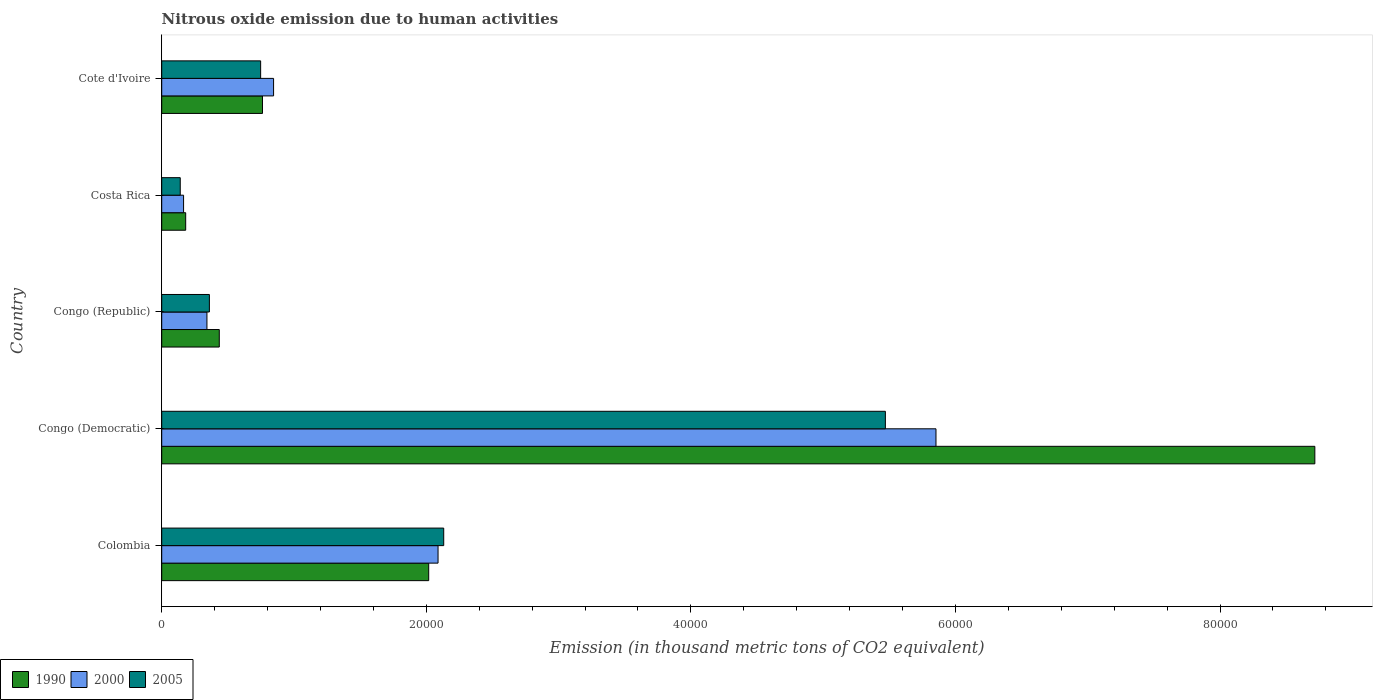How many bars are there on the 3rd tick from the top?
Your answer should be very brief. 3. In how many cases, is the number of bars for a given country not equal to the number of legend labels?
Provide a short and direct response. 0. What is the amount of nitrous oxide emitted in 1990 in Costa Rica?
Make the answer very short. 1812.5. Across all countries, what is the maximum amount of nitrous oxide emitted in 2000?
Provide a succinct answer. 5.85e+04. Across all countries, what is the minimum amount of nitrous oxide emitted in 2005?
Offer a very short reply. 1401. In which country was the amount of nitrous oxide emitted in 1990 maximum?
Offer a very short reply. Congo (Democratic). In which country was the amount of nitrous oxide emitted in 2005 minimum?
Your answer should be very brief. Costa Rica. What is the total amount of nitrous oxide emitted in 1990 in the graph?
Provide a succinct answer. 1.21e+05. What is the difference between the amount of nitrous oxide emitted in 1990 in Congo (Democratic) and that in Cote d'Ivoire?
Keep it short and to the point. 7.95e+04. What is the difference between the amount of nitrous oxide emitted in 1990 in Cote d'Ivoire and the amount of nitrous oxide emitted in 2005 in Costa Rica?
Provide a succinct answer. 6217. What is the average amount of nitrous oxide emitted in 1990 per country?
Ensure brevity in your answer.  2.42e+04. What is the difference between the amount of nitrous oxide emitted in 1990 and amount of nitrous oxide emitted in 2005 in Costa Rica?
Provide a short and direct response. 411.5. What is the ratio of the amount of nitrous oxide emitted in 2000 in Congo (Democratic) to that in Congo (Republic)?
Your answer should be compact. 17.12. Is the amount of nitrous oxide emitted in 2005 in Costa Rica less than that in Cote d'Ivoire?
Provide a short and direct response. Yes. Is the difference between the amount of nitrous oxide emitted in 1990 in Congo (Democratic) and Costa Rica greater than the difference between the amount of nitrous oxide emitted in 2005 in Congo (Democratic) and Costa Rica?
Your answer should be compact. Yes. What is the difference between the highest and the second highest amount of nitrous oxide emitted in 2005?
Make the answer very short. 3.34e+04. What is the difference between the highest and the lowest amount of nitrous oxide emitted in 2000?
Keep it short and to the point. 5.69e+04. What does the 2nd bar from the top in Cote d'Ivoire represents?
Your response must be concise. 2000. How many bars are there?
Make the answer very short. 15. How many countries are there in the graph?
Offer a terse response. 5. What is the difference between two consecutive major ticks on the X-axis?
Offer a terse response. 2.00e+04. Are the values on the major ticks of X-axis written in scientific E-notation?
Offer a very short reply. No. Where does the legend appear in the graph?
Provide a succinct answer. Bottom left. How many legend labels are there?
Keep it short and to the point. 3. How are the legend labels stacked?
Offer a terse response. Horizontal. What is the title of the graph?
Keep it short and to the point. Nitrous oxide emission due to human activities. What is the label or title of the X-axis?
Offer a terse response. Emission (in thousand metric tons of CO2 equivalent). What is the label or title of the Y-axis?
Provide a succinct answer. Country. What is the Emission (in thousand metric tons of CO2 equivalent) of 1990 in Colombia?
Ensure brevity in your answer.  2.02e+04. What is the Emission (in thousand metric tons of CO2 equivalent) in 2000 in Colombia?
Keep it short and to the point. 2.09e+04. What is the Emission (in thousand metric tons of CO2 equivalent) in 2005 in Colombia?
Your answer should be very brief. 2.13e+04. What is the Emission (in thousand metric tons of CO2 equivalent) in 1990 in Congo (Democratic)?
Your response must be concise. 8.72e+04. What is the Emission (in thousand metric tons of CO2 equivalent) in 2000 in Congo (Democratic)?
Ensure brevity in your answer.  5.85e+04. What is the Emission (in thousand metric tons of CO2 equivalent) of 2005 in Congo (Democratic)?
Offer a terse response. 5.47e+04. What is the Emission (in thousand metric tons of CO2 equivalent) in 1990 in Congo (Republic)?
Provide a short and direct response. 4351.5. What is the Emission (in thousand metric tons of CO2 equivalent) in 2000 in Congo (Republic)?
Offer a very short reply. 3418.3. What is the Emission (in thousand metric tons of CO2 equivalent) in 2005 in Congo (Republic)?
Your response must be concise. 3603.5. What is the Emission (in thousand metric tons of CO2 equivalent) in 1990 in Costa Rica?
Your response must be concise. 1812.5. What is the Emission (in thousand metric tons of CO2 equivalent) of 2000 in Costa Rica?
Offer a very short reply. 1653.2. What is the Emission (in thousand metric tons of CO2 equivalent) of 2005 in Costa Rica?
Your answer should be compact. 1401. What is the Emission (in thousand metric tons of CO2 equivalent) in 1990 in Cote d'Ivoire?
Your answer should be very brief. 7618. What is the Emission (in thousand metric tons of CO2 equivalent) of 2000 in Cote d'Ivoire?
Your answer should be compact. 8455.7. What is the Emission (in thousand metric tons of CO2 equivalent) in 2005 in Cote d'Ivoire?
Your answer should be very brief. 7477.7. Across all countries, what is the maximum Emission (in thousand metric tons of CO2 equivalent) in 1990?
Your response must be concise. 8.72e+04. Across all countries, what is the maximum Emission (in thousand metric tons of CO2 equivalent) in 2000?
Make the answer very short. 5.85e+04. Across all countries, what is the maximum Emission (in thousand metric tons of CO2 equivalent) in 2005?
Your answer should be compact. 5.47e+04. Across all countries, what is the minimum Emission (in thousand metric tons of CO2 equivalent) of 1990?
Provide a succinct answer. 1812.5. Across all countries, what is the minimum Emission (in thousand metric tons of CO2 equivalent) in 2000?
Offer a very short reply. 1653.2. Across all countries, what is the minimum Emission (in thousand metric tons of CO2 equivalent) in 2005?
Ensure brevity in your answer.  1401. What is the total Emission (in thousand metric tons of CO2 equivalent) of 1990 in the graph?
Provide a succinct answer. 1.21e+05. What is the total Emission (in thousand metric tons of CO2 equivalent) of 2000 in the graph?
Ensure brevity in your answer.  9.29e+04. What is the total Emission (in thousand metric tons of CO2 equivalent) in 2005 in the graph?
Offer a very short reply. 8.85e+04. What is the difference between the Emission (in thousand metric tons of CO2 equivalent) of 1990 in Colombia and that in Congo (Democratic)?
Ensure brevity in your answer.  -6.70e+04. What is the difference between the Emission (in thousand metric tons of CO2 equivalent) of 2000 in Colombia and that in Congo (Democratic)?
Your response must be concise. -3.76e+04. What is the difference between the Emission (in thousand metric tons of CO2 equivalent) in 2005 in Colombia and that in Congo (Democratic)?
Offer a very short reply. -3.34e+04. What is the difference between the Emission (in thousand metric tons of CO2 equivalent) of 1990 in Colombia and that in Congo (Republic)?
Your answer should be very brief. 1.58e+04. What is the difference between the Emission (in thousand metric tons of CO2 equivalent) in 2000 in Colombia and that in Congo (Republic)?
Keep it short and to the point. 1.75e+04. What is the difference between the Emission (in thousand metric tons of CO2 equivalent) in 2005 in Colombia and that in Congo (Republic)?
Make the answer very short. 1.77e+04. What is the difference between the Emission (in thousand metric tons of CO2 equivalent) of 1990 in Colombia and that in Costa Rica?
Ensure brevity in your answer.  1.84e+04. What is the difference between the Emission (in thousand metric tons of CO2 equivalent) of 2000 in Colombia and that in Costa Rica?
Ensure brevity in your answer.  1.92e+04. What is the difference between the Emission (in thousand metric tons of CO2 equivalent) in 2005 in Colombia and that in Costa Rica?
Make the answer very short. 1.99e+04. What is the difference between the Emission (in thousand metric tons of CO2 equivalent) of 1990 in Colombia and that in Cote d'Ivoire?
Your response must be concise. 1.26e+04. What is the difference between the Emission (in thousand metric tons of CO2 equivalent) of 2000 in Colombia and that in Cote d'Ivoire?
Provide a short and direct response. 1.24e+04. What is the difference between the Emission (in thousand metric tons of CO2 equivalent) of 2005 in Colombia and that in Cote d'Ivoire?
Make the answer very short. 1.38e+04. What is the difference between the Emission (in thousand metric tons of CO2 equivalent) of 1990 in Congo (Democratic) and that in Congo (Republic)?
Provide a succinct answer. 8.28e+04. What is the difference between the Emission (in thousand metric tons of CO2 equivalent) in 2000 in Congo (Democratic) and that in Congo (Republic)?
Provide a short and direct response. 5.51e+04. What is the difference between the Emission (in thousand metric tons of CO2 equivalent) of 2005 in Congo (Democratic) and that in Congo (Republic)?
Your answer should be compact. 5.11e+04. What is the difference between the Emission (in thousand metric tons of CO2 equivalent) of 1990 in Congo (Democratic) and that in Costa Rica?
Offer a terse response. 8.54e+04. What is the difference between the Emission (in thousand metric tons of CO2 equivalent) in 2000 in Congo (Democratic) and that in Costa Rica?
Provide a succinct answer. 5.69e+04. What is the difference between the Emission (in thousand metric tons of CO2 equivalent) in 2005 in Congo (Democratic) and that in Costa Rica?
Ensure brevity in your answer.  5.33e+04. What is the difference between the Emission (in thousand metric tons of CO2 equivalent) in 1990 in Congo (Democratic) and that in Cote d'Ivoire?
Keep it short and to the point. 7.95e+04. What is the difference between the Emission (in thousand metric tons of CO2 equivalent) in 2000 in Congo (Democratic) and that in Cote d'Ivoire?
Give a very brief answer. 5.01e+04. What is the difference between the Emission (in thousand metric tons of CO2 equivalent) of 2005 in Congo (Democratic) and that in Cote d'Ivoire?
Ensure brevity in your answer.  4.72e+04. What is the difference between the Emission (in thousand metric tons of CO2 equivalent) of 1990 in Congo (Republic) and that in Costa Rica?
Your response must be concise. 2539. What is the difference between the Emission (in thousand metric tons of CO2 equivalent) in 2000 in Congo (Republic) and that in Costa Rica?
Ensure brevity in your answer.  1765.1. What is the difference between the Emission (in thousand metric tons of CO2 equivalent) of 2005 in Congo (Republic) and that in Costa Rica?
Provide a short and direct response. 2202.5. What is the difference between the Emission (in thousand metric tons of CO2 equivalent) in 1990 in Congo (Republic) and that in Cote d'Ivoire?
Give a very brief answer. -3266.5. What is the difference between the Emission (in thousand metric tons of CO2 equivalent) in 2000 in Congo (Republic) and that in Cote d'Ivoire?
Keep it short and to the point. -5037.4. What is the difference between the Emission (in thousand metric tons of CO2 equivalent) in 2005 in Congo (Republic) and that in Cote d'Ivoire?
Your response must be concise. -3874.2. What is the difference between the Emission (in thousand metric tons of CO2 equivalent) of 1990 in Costa Rica and that in Cote d'Ivoire?
Ensure brevity in your answer.  -5805.5. What is the difference between the Emission (in thousand metric tons of CO2 equivalent) in 2000 in Costa Rica and that in Cote d'Ivoire?
Give a very brief answer. -6802.5. What is the difference between the Emission (in thousand metric tons of CO2 equivalent) of 2005 in Costa Rica and that in Cote d'Ivoire?
Give a very brief answer. -6076.7. What is the difference between the Emission (in thousand metric tons of CO2 equivalent) of 1990 in Colombia and the Emission (in thousand metric tons of CO2 equivalent) of 2000 in Congo (Democratic)?
Give a very brief answer. -3.83e+04. What is the difference between the Emission (in thousand metric tons of CO2 equivalent) of 1990 in Colombia and the Emission (in thousand metric tons of CO2 equivalent) of 2005 in Congo (Democratic)?
Provide a succinct answer. -3.45e+04. What is the difference between the Emission (in thousand metric tons of CO2 equivalent) in 2000 in Colombia and the Emission (in thousand metric tons of CO2 equivalent) in 2005 in Congo (Democratic)?
Keep it short and to the point. -3.38e+04. What is the difference between the Emission (in thousand metric tons of CO2 equivalent) of 1990 in Colombia and the Emission (in thousand metric tons of CO2 equivalent) of 2000 in Congo (Republic)?
Offer a very short reply. 1.68e+04. What is the difference between the Emission (in thousand metric tons of CO2 equivalent) in 1990 in Colombia and the Emission (in thousand metric tons of CO2 equivalent) in 2005 in Congo (Republic)?
Offer a very short reply. 1.66e+04. What is the difference between the Emission (in thousand metric tons of CO2 equivalent) of 2000 in Colombia and the Emission (in thousand metric tons of CO2 equivalent) of 2005 in Congo (Republic)?
Give a very brief answer. 1.73e+04. What is the difference between the Emission (in thousand metric tons of CO2 equivalent) of 1990 in Colombia and the Emission (in thousand metric tons of CO2 equivalent) of 2000 in Costa Rica?
Make the answer very short. 1.85e+04. What is the difference between the Emission (in thousand metric tons of CO2 equivalent) of 1990 in Colombia and the Emission (in thousand metric tons of CO2 equivalent) of 2005 in Costa Rica?
Your response must be concise. 1.88e+04. What is the difference between the Emission (in thousand metric tons of CO2 equivalent) in 2000 in Colombia and the Emission (in thousand metric tons of CO2 equivalent) in 2005 in Costa Rica?
Keep it short and to the point. 1.95e+04. What is the difference between the Emission (in thousand metric tons of CO2 equivalent) of 1990 in Colombia and the Emission (in thousand metric tons of CO2 equivalent) of 2000 in Cote d'Ivoire?
Offer a very short reply. 1.17e+04. What is the difference between the Emission (in thousand metric tons of CO2 equivalent) of 1990 in Colombia and the Emission (in thousand metric tons of CO2 equivalent) of 2005 in Cote d'Ivoire?
Provide a succinct answer. 1.27e+04. What is the difference between the Emission (in thousand metric tons of CO2 equivalent) of 2000 in Colombia and the Emission (in thousand metric tons of CO2 equivalent) of 2005 in Cote d'Ivoire?
Your answer should be compact. 1.34e+04. What is the difference between the Emission (in thousand metric tons of CO2 equivalent) in 1990 in Congo (Democratic) and the Emission (in thousand metric tons of CO2 equivalent) in 2000 in Congo (Republic)?
Make the answer very short. 8.37e+04. What is the difference between the Emission (in thousand metric tons of CO2 equivalent) of 1990 in Congo (Democratic) and the Emission (in thousand metric tons of CO2 equivalent) of 2005 in Congo (Republic)?
Ensure brevity in your answer.  8.36e+04. What is the difference between the Emission (in thousand metric tons of CO2 equivalent) in 2000 in Congo (Democratic) and the Emission (in thousand metric tons of CO2 equivalent) in 2005 in Congo (Republic)?
Give a very brief answer. 5.49e+04. What is the difference between the Emission (in thousand metric tons of CO2 equivalent) of 1990 in Congo (Democratic) and the Emission (in thousand metric tons of CO2 equivalent) of 2000 in Costa Rica?
Your answer should be very brief. 8.55e+04. What is the difference between the Emission (in thousand metric tons of CO2 equivalent) of 1990 in Congo (Democratic) and the Emission (in thousand metric tons of CO2 equivalent) of 2005 in Costa Rica?
Your answer should be very brief. 8.58e+04. What is the difference between the Emission (in thousand metric tons of CO2 equivalent) of 2000 in Congo (Democratic) and the Emission (in thousand metric tons of CO2 equivalent) of 2005 in Costa Rica?
Ensure brevity in your answer.  5.71e+04. What is the difference between the Emission (in thousand metric tons of CO2 equivalent) of 1990 in Congo (Democratic) and the Emission (in thousand metric tons of CO2 equivalent) of 2000 in Cote d'Ivoire?
Your response must be concise. 7.87e+04. What is the difference between the Emission (in thousand metric tons of CO2 equivalent) in 1990 in Congo (Democratic) and the Emission (in thousand metric tons of CO2 equivalent) in 2005 in Cote d'Ivoire?
Ensure brevity in your answer.  7.97e+04. What is the difference between the Emission (in thousand metric tons of CO2 equivalent) of 2000 in Congo (Democratic) and the Emission (in thousand metric tons of CO2 equivalent) of 2005 in Cote d'Ivoire?
Your answer should be compact. 5.11e+04. What is the difference between the Emission (in thousand metric tons of CO2 equivalent) of 1990 in Congo (Republic) and the Emission (in thousand metric tons of CO2 equivalent) of 2000 in Costa Rica?
Keep it short and to the point. 2698.3. What is the difference between the Emission (in thousand metric tons of CO2 equivalent) of 1990 in Congo (Republic) and the Emission (in thousand metric tons of CO2 equivalent) of 2005 in Costa Rica?
Make the answer very short. 2950.5. What is the difference between the Emission (in thousand metric tons of CO2 equivalent) in 2000 in Congo (Republic) and the Emission (in thousand metric tons of CO2 equivalent) in 2005 in Costa Rica?
Provide a succinct answer. 2017.3. What is the difference between the Emission (in thousand metric tons of CO2 equivalent) in 1990 in Congo (Republic) and the Emission (in thousand metric tons of CO2 equivalent) in 2000 in Cote d'Ivoire?
Give a very brief answer. -4104.2. What is the difference between the Emission (in thousand metric tons of CO2 equivalent) in 1990 in Congo (Republic) and the Emission (in thousand metric tons of CO2 equivalent) in 2005 in Cote d'Ivoire?
Make the answer very short. -3126.2. What is the difference between the Emission (in thousand metric tons of CO2 equivalent) of 2000 in Congo (Republic) and the Emission (in thousand metric tons of CO2 equivalent) of 2005 in Cote d'Ivoire?
Make the answer very short. -4059.4. What is the difference between the Emission (in thousand metric tons of CO2 equivalent) of 1990 in Costa Rica and the Emission (in thousand metric tons of CO2 equivalent) of 2000 in Cote d'Ivoire?
Provide a short and direct response. -6643.2. What is the difference between the Emission (in thousand metric tons of CO2 equivalent) of 1990 in Costa Rica and the Emission (in thousand metric tons of CO2 equivalent) of 2005 in Cote d'Ivoire?
Give a very brief answer. -5665.2. What is the difference between the Emission (in thousand metric tons of CO2 equivalent) in 2000 in Costa Rica and the Emission (in thousand metric tons of CO2 equivalent) in 2005 in Cote d'Ivoire?
Provide a succinct answer. -5824.5. What is the average Emission (in thousand metric tons of CO2 equivalent) of 1990 per country?
Give a very brief answer. 2.42e+04. What is the average Emission (in thousand metric tons of CO2 equivalent) of 2000 per country?
Keep it short and to the point. 1.86e+04. What is the average Emission (in thousand metric tons of CO2 equivalent) in 2005 per country?
Your response must be concise. 1.77e+04. What is the difference between the Emission (in thousand metric tons of CO2 equivalent) in 1990 and Emission (in thousand metric tons of CO2 equivalent) in 2000 in Colombia?
Give a very brief answer. -706.7. What is the difference between the Emission (in thousand metric tons of CO2 equivalent) of 1990 and Emission (in thousand metric tons of CO2 equivalent) of 2005 in Colombia?
Give a very brief answer. -1134.8. What is the difference between the Emission (in thousand metric tons of CO2 equivalent) of 2000 and Emission (in thousand metric tons of CO2 equivalent) of 2005 in Colombia?
Your answer should be compact. -428.1. What is the difference between the Emission (in thousand metric tons of CO2 equivalent) of 1990 and Emission (in thousand metric tons of CO2 equivalent) of 2000 in Congo (Democratic)?
Your answer should be compact. 2.86e+04. What is the difference between the Emission (in thousand metric tons of CO2 equivalent) of 1990 and Emission (in thousand metric tons of CO2 equivalent) of 2005 in Congo (Democratic)?
Offer a very short reply. 3.25e+04. What is the difference between the Emission (in thousand metric tons of CO2 equivalent) of 2000 and Emission (in thousand metric tons of CO2 equivalent) of 2005 in Congo (Democratic)?
Give a very brief answer. 3826.5. What is the difference between the Emission (in thousand metric tons of CO2 equivalent) in 1990 and Emission (in thousand metric tons of CO2 equivalent) in 2000 in Congo (Republic)?
Give a very brief answer. 933.2. What is the difference between the Emission (in thousand metric tons of CO2 equivalent) of 1990 and Emission (in thousand metric tons of CO2 equivalent) of 2005 in Congo (Republic)?
Make the answer very short. 748. What is the difference between the Emission (in thousand metric tons of CO2 equivalent) of 2000 and Emission (in thousand metric tons of CO2 equivalent) of 2005 in Congo (Republic)?
Give a very brief answer. -185.2. What is the difference between the Emission (in thousand metric tons of CO2 equivalent) in 1990 and Emission (in thousand metric tons of CO2 equivalent) in 2000 in Costa Rica?
Make the answer very short. 159.3. What is the difference between the Emission (in thousand metric tons of CO2 equivalent) in 1990 and Emission (in thousand metric tons of CO2 equivalent) in 2005 in Costa Rica?
Offer a very short reply. 411.5. What is the difference between the Emission (in thousand metric tons of CO2 equivalent) of 2000 and Emission (in thousand metric tons of CO2 equivalent) of 2005 in Costa Rica?
Keep it short and to the point. 252.2. What is the difference between the Emission (in thousand metric tons of CO2 equivalent) in 1990 and Emission (in thousand metric tons of CO2 equivalent) in 2000 in Cote d'Ivoire?
Your response must be concise. -837.7. What is the difference between the Emission (in thousand metric tons of CO2 equivalent) in 1990 and Emission (in thousand metric tons of CO2 equivalent) in 2005 in Cote d'Ivoire?
Offer a very short reply. 140.3. What is the difference between the Emission (in thousand metric tons of CO2 equivalent) in 2000 and Emission (in thousand metric tons of CO2 equivalent) in 2005 in Cote d'Ivoire?
Ensure brevity in your answer.  978. What is the ratio of the Emission (in thousand metric tons of CO2 equivalent) of 1990 in Colombia to that in Congo (Democratic)?
Make the answer very short. 0.23. What is the ratio of the Emission (in thousand metric tons of CO2 equivalent) of 2000 in Colombia to that in Congo (Democratic)?
Offer a very short reply. 0.36. What is the ratio of the Emission (in thousand metric tons of CO2 equivalent) in 2005 in Colombia to that in Congo (Democratic)?
Ensure brevity in your answer.  0.39. What is the ratio of the Emission (in thousand metric tons of CO2 equivalent) of 1990 in Colombia to that in Congo (Republic)?
Your response must be concise. 4.64. What is the ratio of the Emission (in thousand metric tons of CO2 equivalent) of 2000 in Colombia to that in Congo (Republic)?
Offer a terse response. 6.11. What is the ratio of the Emission (in thousand metric tons of CO2 equivalent) in 2005 in Colombia to that in Congo (Republic)?
Offer a terse response. 5.92. What is the ratio of the Emission (in thousand metric tons of CO2 equivalent) of 1990 in Colombia to that in Costa Rica?
Your answer should be very brief. 11.13. What is the ratio of the Emission (in thousand metric tons of CO2 equivalent) of 2000 in Colombia to that in Costa Rica?
Your answer should be very brief. 12.64. What is the ratio of the Emission (in thousand metric tons of CO2 equivalent) in 2005 in Colombia to that in Costa Rica?
Provide a short and direct response. 15.22. What is the ratio of the Emission (in thousand metric tons of CO2 equivalent) in 1990 in Colombia to that in Cote d'Ivoire?
Ensure brevity in your answer.  2.65. What is the ratio of the Emission (in thousand metric tons of CO2 equivalent) in 2000 in Colombia to that in Cote d'Ivoire?
Your answer should be very brief. 2.47. What is the ratio of the Emission (in thousand metric tons of CO2 equivalent) in 2005 in Colombia to that in Cote d'Ivoire?
Your response must be concise. 2.85. What is the ratio of the Emission (in thousand metric tons of CO2 equivalent) of 1990 in Congo (Democratic) to that in Congo (Republic)?
Your answer should be compact. 20.03. What is the ratio of the Emission (in thousand metric tons of CO2 equivalent) in 2000 in Congo (Democratic) to that in Congo (Republic)?
Offer a very short reply. 17.12. What is the ratio of the Emission (in thousand metric tons of CO2 equivalent) of 2005 in Congo (Democratic) to that in Congo (Republic)?
Your answer should be very brief. 15.18. What is the ratio of the Emission (in thousand metric tons of CO2 equivalent) in 1990 in Congo (Democratic) to that in Costa Rica?
Keep it short and to the point. 48.09. What is the ratio of the Emission (in thousand metric tons of CO2 equivalent) in 2000 in Congo (Democratic) to that in Costa Rica?
Offer a terse response. 35.4. What is the ratio of the Emission (in thousand metric tons of CO2 equivalent) of 2005 in Congo (Democratic) to that in Costa Rica?
Your answer should be compact. 39.04. What is the ratio of the Emission (in thousand metric tons of CO2 equivalent) in 1990 in Congo (Democratic) to that in Cote d'Ivoire?
Your answer should be very brief. 11.44. What is the ratio of the Emission (in thousand metric tons of CO2 equivalent) of 2000 in Congo (Democratic) to that in Cote d'Ivoire?
Ensure brevity in your answer.  6.92. What is the ratio of the Emission (in thousand metric tons of CO2 equivalent) of 2005 in Congo (Democratic) to that in Cote d'Ivoire?
Make the answer very short. 7.32. What is the ratio of the Emission (in thousand metric tons of CO2 equivalent) in 1990 in Congo (Republic) to that in Costa Rica?
Give a very brief answer. 2.4. What is the ratio of the Emission (in thousand metric tons of CO2 equivalent) of 2000 in Congo (Republic) to that in Costa Rica?
Provide a succinct answer. 2.07. What is the ratio of the Emission (in thousand metric tons of CO2 equivalent) in 2005 in Congo (Republic) to that in Costa Rica?
Provide a short and direct response. 2.57. What is the ratio of the Emission (in thousand metric tons of CO2 equivalent) of 1990 in Congo (Republic) to that in Cote d'Ivoire?
Keep it short and to the point. 0.57. What is the ratio of the Emission (in thousand metric tons of CO2 equivalent) of 2000 in Congo (Republic) to that in Cote d'Ivoire?
Make the answer very short. 0.4. What is the ratio of the Emission (in thousand metric tons of CO2 equivalent) of 2005 in Congo (Republic) to that in Cote d'Ivoire?
Your answer should be very brief. 0.48. What is the ratio of the Emission (in thousand metric tons of CO2 equivalent) of 1990 in Costa Rica to that in Cote d'Ivoire?
Offer a terse response. 0.24. What is the ratio of the Emission (in thousand metric tons of CO2 equivalent) of 2000 in Costa Rica to that in Cote d'Ivoire?
Your answer should be compact. 0.2. What is the ratio of the Emission (in thousand metric tons of CO2 equivalent) in 2005 in Costa Rica to that in Cote d'Ivoire?
Your response must be concise. 0.19. What is the difference between the highest and the second highest Emission (in thousand metric tons of CO2 equivalent) of 1990?
Make the answer very short. 6.70e+04. What is the difference between the highest and the second highest Emission (in thousand metric tons of CO2 equivalent) in 2000?
Offer a very short reply. 3.76e+04. What is the difference between the highest and the second highest Emission (in thousand metric tons of CO2 equivalent) in 2005?
Your answer should be very brief. 3.34e+04. What is the difference between the highest and the lowest Emission (in thousand metric tons of CO2 equivalent) of 1990?
Your answer should be very brief. 8.54e+04. What is the difference between the highest and the lowest Emission (in thousand metric tons of CO2 equivalent) of 2000?
Ensure brevity in your answer.  5.69e+04. What is the difference between the highest and the lowest Emission (in thousand metric tons of CO2 equivalent) of 2005?
Keep it short and to the point. 5.33e+04. 